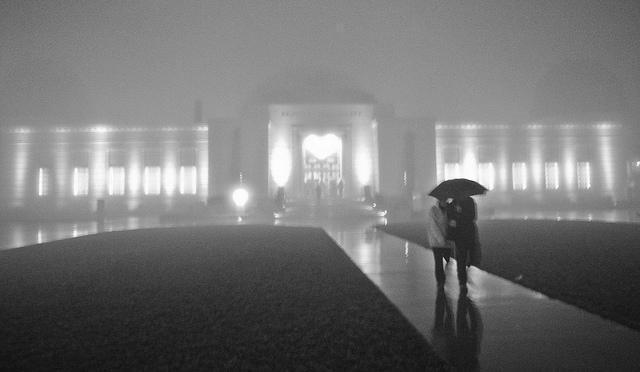What time of day is it?
Indicate the correct response and explain using: 'Answer: answer
Rationale: rationale.'
Options: Midnight, dusk, noon, mid morning. Answer: dusk.
Rationale: You can tell by how the building is lit up the time of day. 